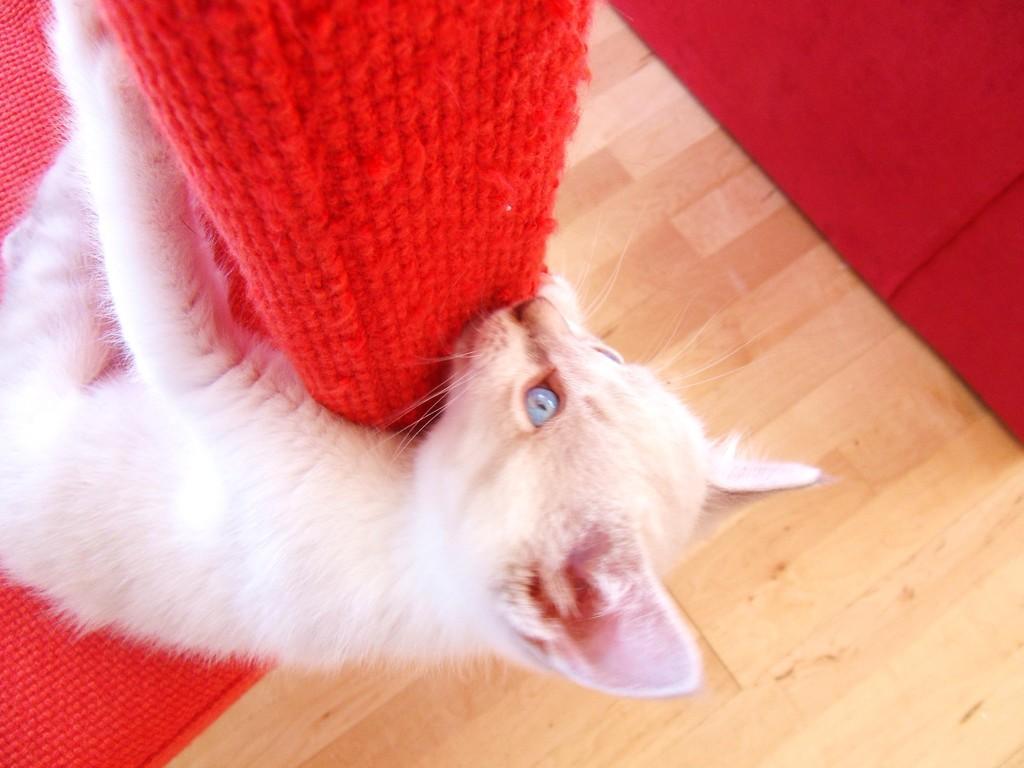In one or two sentences, can you explain what this image depicts? This is a cat, which is holding a mat. This cat looks red in color. Here is the floor. On the right side of the image, that looks like another mat, which is lying on the floor. 